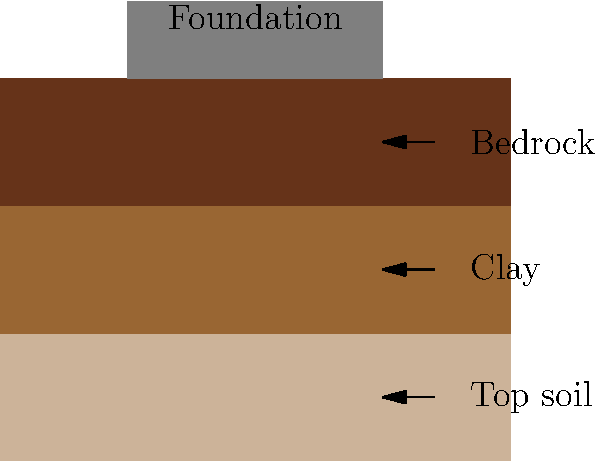In the cutaway diagram of soil layers and a building foundation, which layer is most suitable for supporting the foundation, and why is it important to consider soil composition when designing foundations? To answer this question, let's analyze the soil layers and their properties:

1. Top soil: This is the uppermost layer, typically loose and organic. It's not suitable for supporting foundations due to its low bearing capacity and potential for settling.

2. Clay: The middle layer is clay, which can be problematic for foundations. Clay expands when wet and shrinks when dry, causing potential foundation movement.

3. Bedrock: The bottom layer is bedrock, which is the most suitable for supporting foundations due to its high bearing capacity and stability.

The importance of considering soil composition when designing foundations:

1. Bearing capacity: Different soil types have varying abilities to support loads. Bedrock has the highest bearing capacity, followed by compacted soils, while loose or organic soils have the lowest.

2. Settlement: Soils with low bearing capacity or high compressibility (like clay) can lead to uneven settlement, causing structural damage.

3. Soil stability: Some soils, like expansive clays, can change volume with moisture content, potentially causing foundation movement.

4. Drainage: Soil composition affects water drainage, which can impact foundation stability and potential water damage.

5. Frost heave: In colder climates, soil composition influences susceptibility to frost heave, which can damage foundations.

6. Cost-effectiveness: Understanding soil composition helps in designing appropriate foundation types and depths, optimizing construction costs.

In this case, the bedrock layer is the most suitable for supporting the foundation due to its stability and high bearing capacity. Proper soil analysis ensures safe, stable, and long-lasting building foundations.
Answer: Bedrock; soil composition affects bearing capacity, settlement, stability, drainage, and construction costs. 